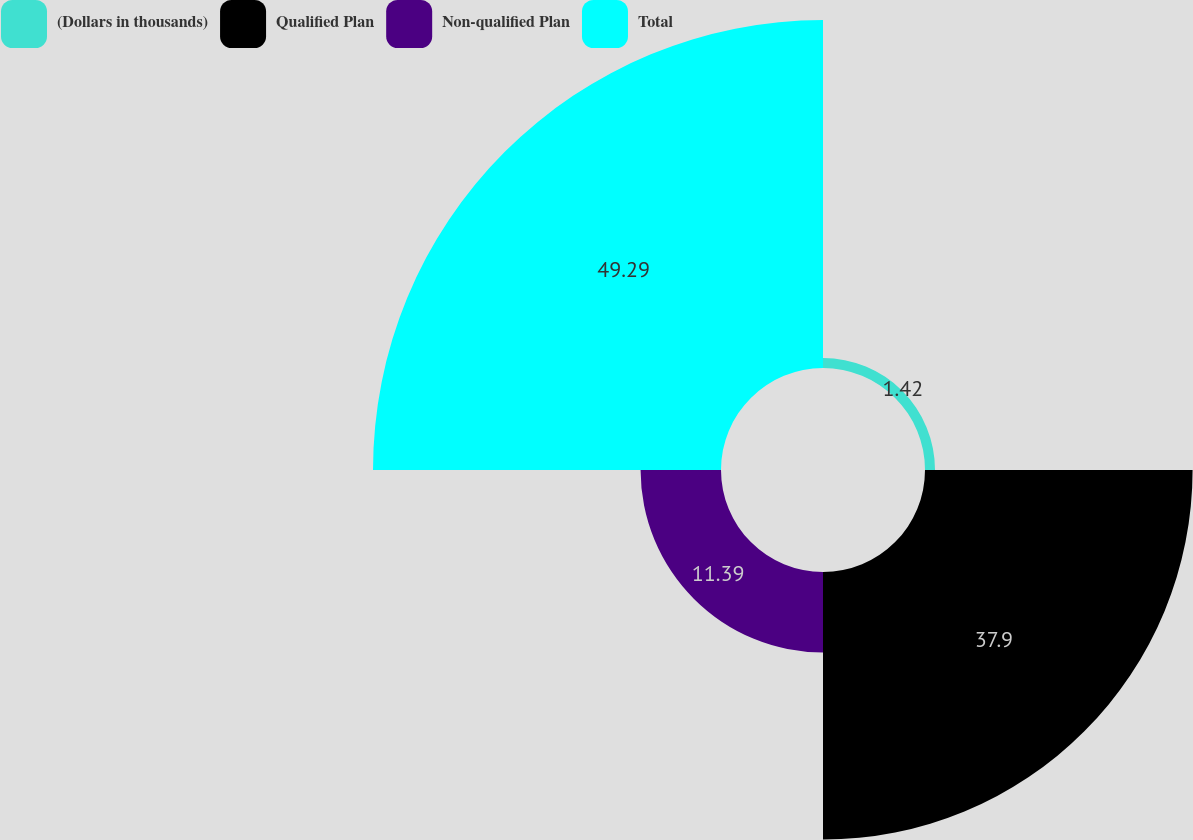Convert chart to OTSL. <chart><loc_0><loc_0><loc_500><loc_500><pie_chart><fcel>(Dollars in thousands)<fcel>Qualified Plan<fcel>Non-qualified Plan<fcel>Total<nl><fcel>1.42%<fcel>37.9%<fcel>11.39%<fcel>49.29%<nl></chart> 